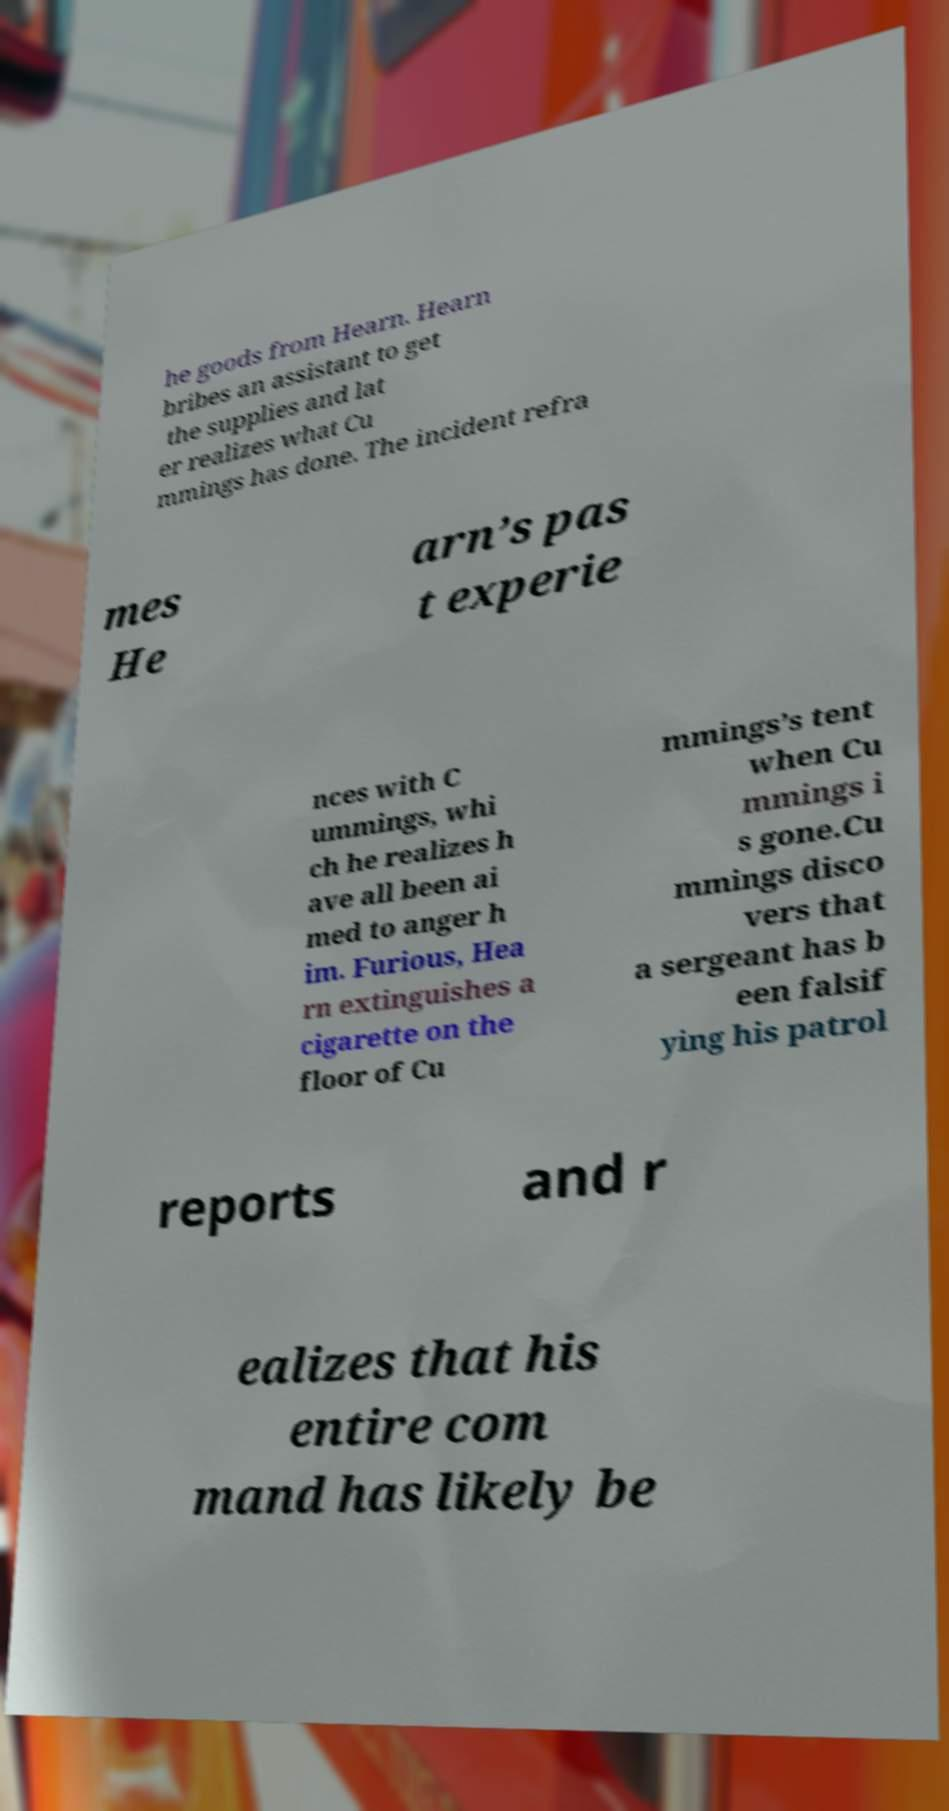Could you assist in decoding the text presented in this image and type it out clearly? he goods from Hearn. Hearn bribes an assistant to get the supplies and lat er realizes what Cu mmings has done. The incident refra mes He arn’s pas t experie nces with C ummings, whi ch he realizes h ave all been ai med to anger h im. Furious, Hea rn extinguishes a cigarette on the floor of Cu mmings’s tent when Cu mmings i s gone.Cu mmings disco vers that a sergeant has b een falsif ying his patrol reports and r ealizes that his entire com mand has likely be 